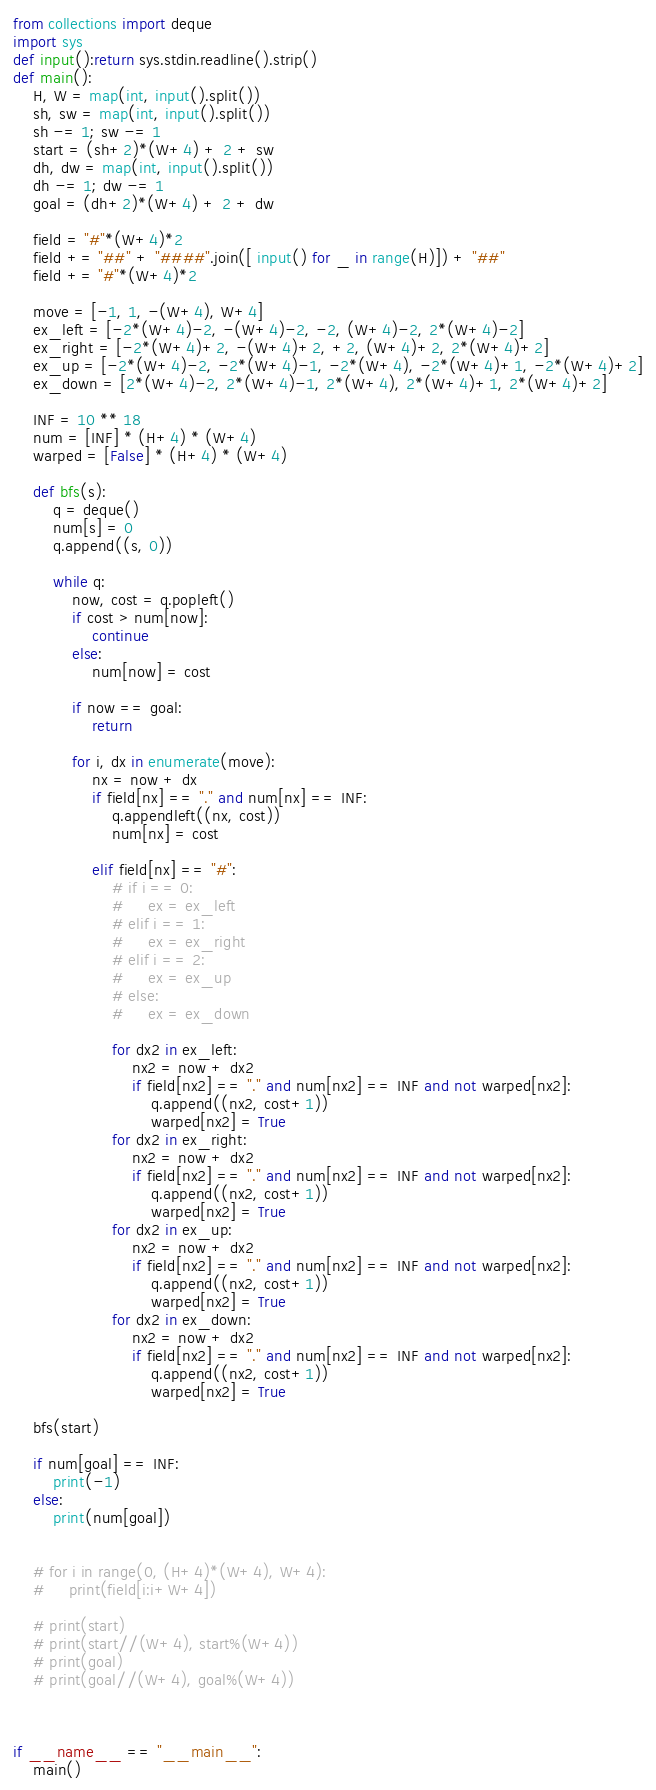<code> <loc_0><loc_0><loc_500><loc_500><_Python_>from collections import deque
import sys
def input():return sys.stdin.readline().strip()
def main():
    H, W = map(int, input().split())
    sh, sw = map(int, input().split())
    sh -= 1; sw -= 1
    start = (sh+2)*(W+4) + 2 + sw
    dh, dw = map(int, input().split())
    dh -= 1; dw -= 1
    goal = (dh+2)*(W+4) + 2 + dw

    field = "#"*(W+4)*2
    field += "##" + "####".join([ input() for _ in range(H)]) + "##"
    field += "#"*(W+4)*2

    move = [-1, 1, -(W+4), W+4]
    ex_left = [-2*(W+4)-2, -(W+4)-2, -2, (W+4)-2, 2*(W+4)-2]
    ex_right = [-2*(W+4)+2, -(W+4)+2, +2, (W+4)+2, 2*(W+4)+2]
    ex_up = [-2*(W+4)-2, -2*(W+4)-1, -2*(W+4), -2*(W+4)+1, -2*(W+4)+2]
    ex_down = [2*(W+4)-2, 2*(W+4)-1, 2*(W+4), 2*(W+4)+1, 2*(W+4)+2]

    INF = 10 ** 18
    num = [INF] * (H+4) * (W+4)
    warped = [False] * (H+4) * (W+4)

    def bfs(s):
        q = deque()
        num[s] = 0
        q.append((s, 0))
    
        while q:
            now, cost = q.popleft()
            if cost > num[now]:
                continue
            else:
                num[now] = cost

            if now == goal:
                return

            for i, dx in enumerate(move):
                nx = now + dx
                if field[nx] == "." and num[nx] == INF:
                    q.appendleft((nx, cost))
                    num[nx] = cost

                elif field[nx] == "#":
                    # if i == 0:
                    #     ex = ex_left
                    # elif i == 1:
                    #     ex = ex_right
                    # elif i == 2:
                    #     ex = ex_up
                    # else:
                    #     ex = ex_down

                    for dx2 in ex_left:
                        nx2 = now + dx2
                        if field[nx2] == "." and num[nx2] == INF and not warped[nx2]:
                            q.append((nx2, cost+1))
                            warped[nx2] = True
                    for dx2 in ex_right:
                        nx2 = now + dx2
                        if field[nx2] == "." and num[nx2] == INF and not warped[nx2]:
                            q.append((nx2, cost+1))
                            warped[nx2] = True
                    for dx2 in ex_up:
                        nx2 = now + dx2
                        if field[nx2] == "." and num[nx2] == INF and not warped[nx2]:
                            q.append((nx2, cost+1))
                            warped[nx2] = True
                    for dx2 in ex_down:
                        nx2 = now + dx2
                        if field[nx2] == "." and num[nx2] == INF and not warped[nx2]:
                            q.append((nx2, cost+1))
                            warped[nx2] = True
    
    bfs(start)

    if num[goal] == INF:
        print(-1)
    else:
        print(num[goal])

    
    # for i in range(0, (H+4)*(W+4), W+4):
    #     print(field[i:i+W+4])
    
    # print(start)
    # print(start//(W+4), start%(W+4))
    # print(goal)
    # print(goal//(W+4), goal%(W+4))
    


if __name__ == "__main__":
    main()</code> 